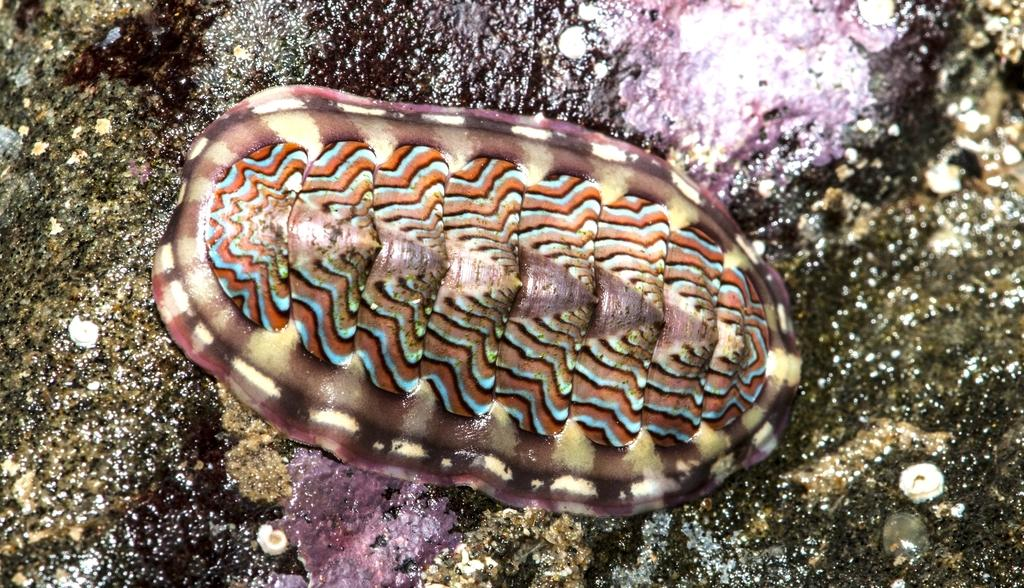What type of animal is in the image? There is a small tortoise in the image. What is unique about the tortoise's appearance? The shell of the tortoise has multiple colors. What advice does the tortoise's grandmother give in the image? There is no grandmother or advice present in the image, as it only features a small tortoise with a colorful shell. 